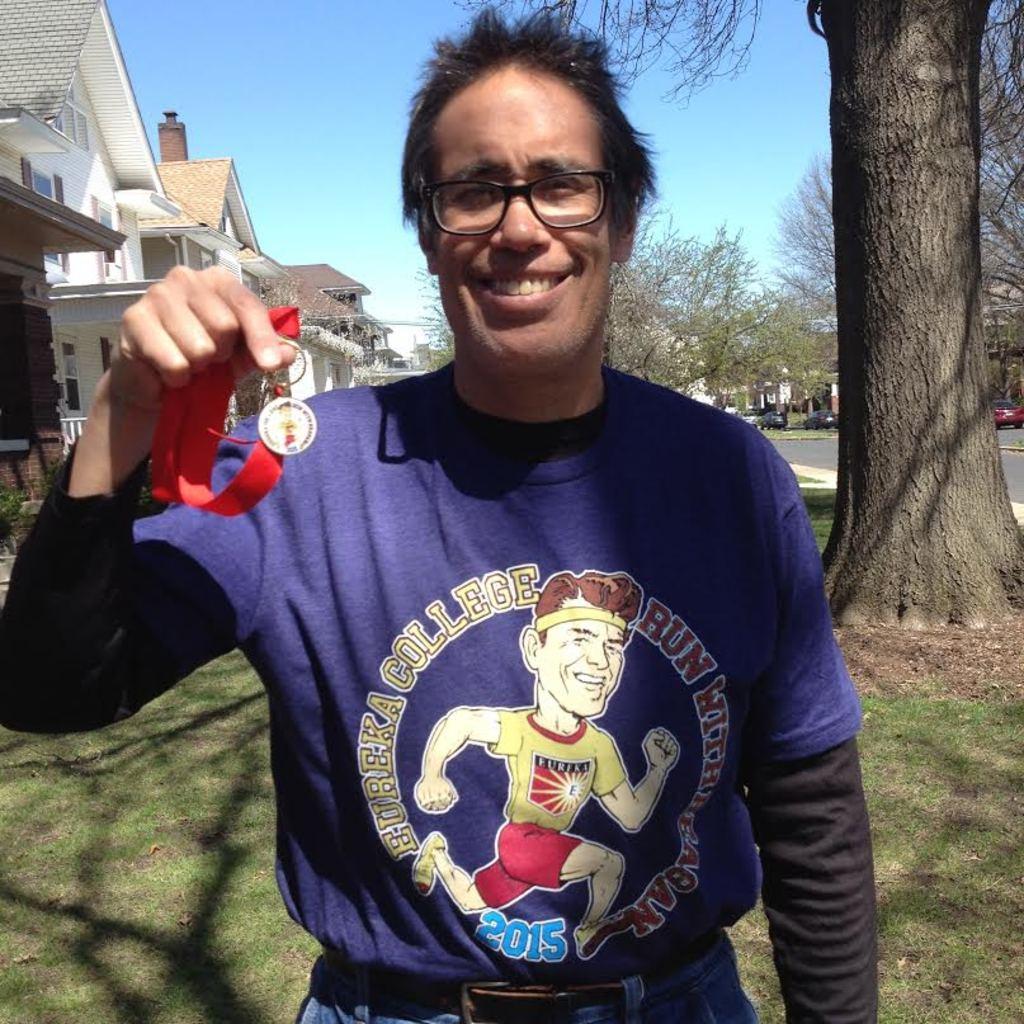Can you describe this image briefly? In this image we can see a man holding a medal with his hands. He wore spectacles and he is smiling. Here we can see grass, road, vehicles, trees, and houses. In the background there is sky. 